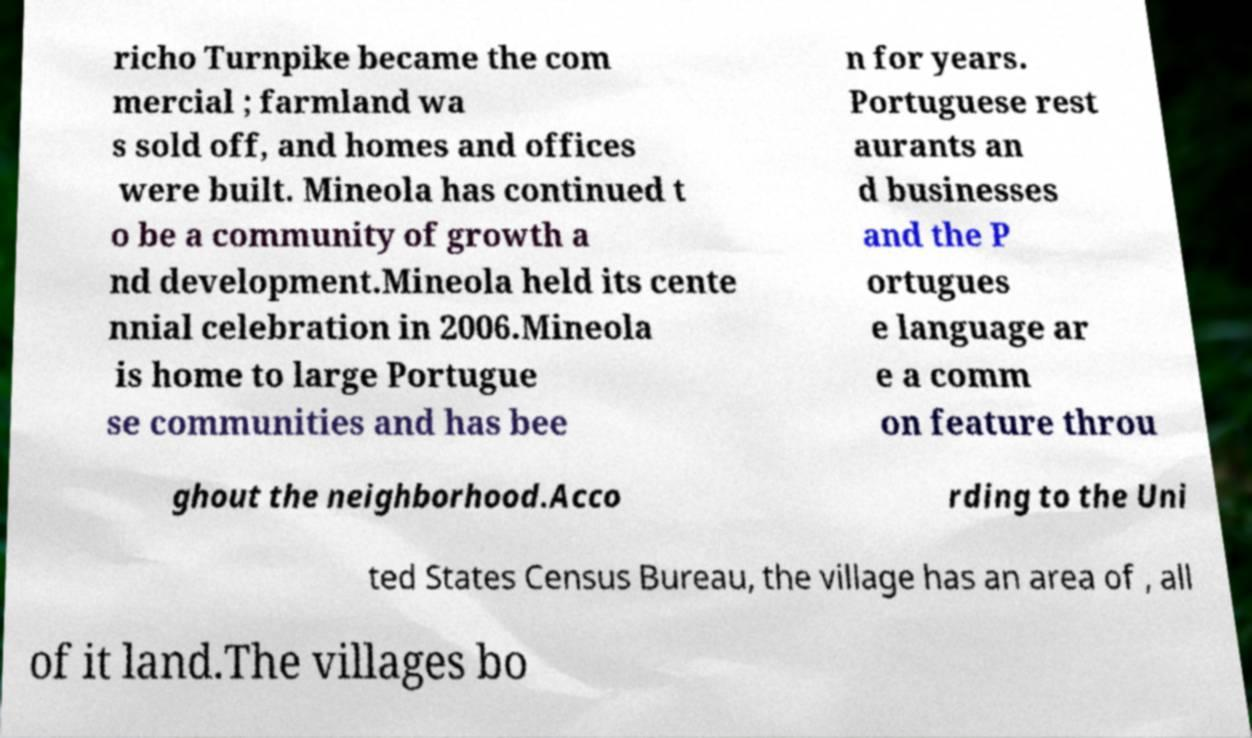What messages or text are displayed in this image? I need them in a readable, typed format. richo Turnpike became the com mercial ; farmland wa s sold off, and homes and offices were built. Mineola has continued t o be a community of growth a nd development.Mineola held its cente nnial celebration in 2006.Mineola is home to large Portugue se communities and has bee n for years. Portuguese rest aurants an d businesses and the P ortugues e language ar e a comm on feature throu ghout the neighborhood.Acco rding to the Uni ted States Census Bureau, the village has an area of , all of it land.The villages bo 